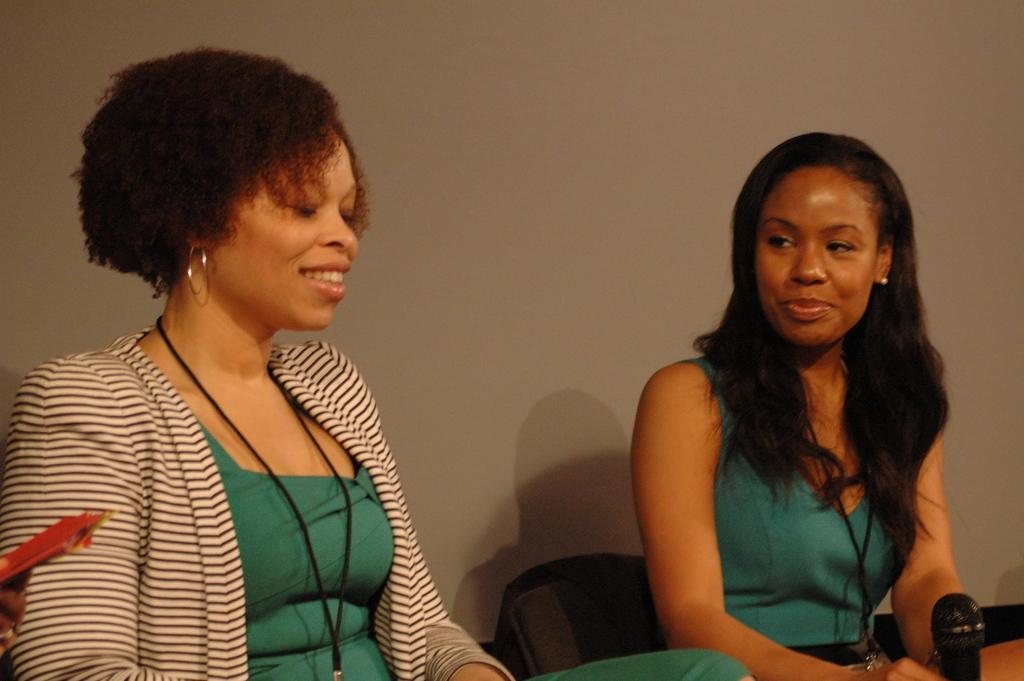Can you describe this image briefly? This image consist of two women sitting in a room. In the background there is a wall. To the left, the woman sitting is wearing green dress and white jacket. To the right, the woman sitting is wearing green dress in front of her there is a mic. 